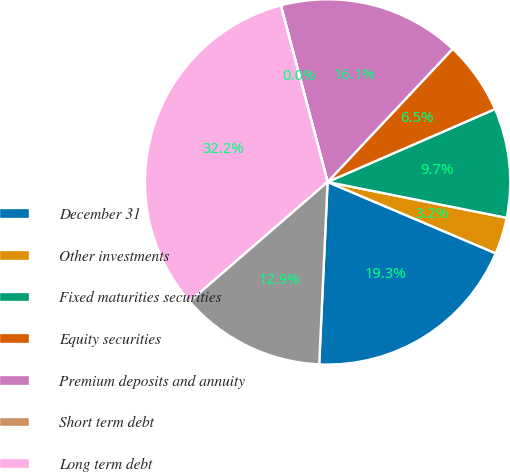Convert chart. <chart><loc_0><loc_0><loc_500><loc_500><pie_chart><fcel>December 31<fcel>Other investments<fcel>Fixed maturities securities<fcel>Equity securities<fcel>Premium deposits and annuity<fcel>Short term debt<fcel>Long term debt<fcel>Separate account business<nl><fcel>19.34%<fcel>3.24%<fcel>9.68%<fcel>6.46%<fcel>16.12%<fcel>0.02%<fcel>32.22%<fcel>12.9%<nl></chart> 